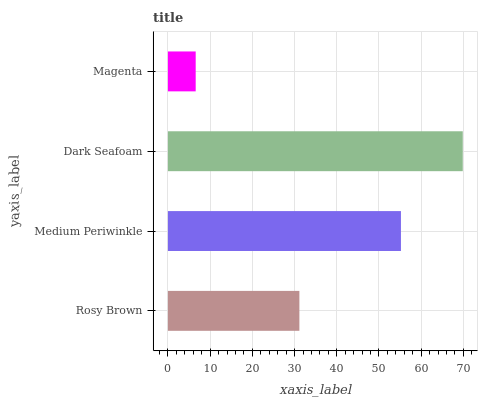Is Magenta the minimum?
Answer yes or no. Yes. Is Dark Seafoam the maximum?
Answer yes or no. Yes. Is Medium Periwinkle the minimum?
Answer yes or no. No. Is Medium Periwinkle the maximum?
Answer yes or no. No. Is Medium Periwinkle greater than Rosy Brown?
Answer yes or no. Yes. Is Rosy Brown less than Medium Periwinkle?
Answer yes or no. Yes. Is Rosy Brown greater than Medium Periwinkle?
Answer yes or no. No. Is Medium Periwinkle less than Rosy Brown?
Answer yes or no. No. Is Medium Periwinkle the high median?
Answer yes or no. Yes. Is Rosy Brown the low median?
Answer yes or no. Yes. Is Dark Seafoam the high median?
Answer yes or no. No. Is Medium Periwinkle the low median?
Answer yes or no. No. 